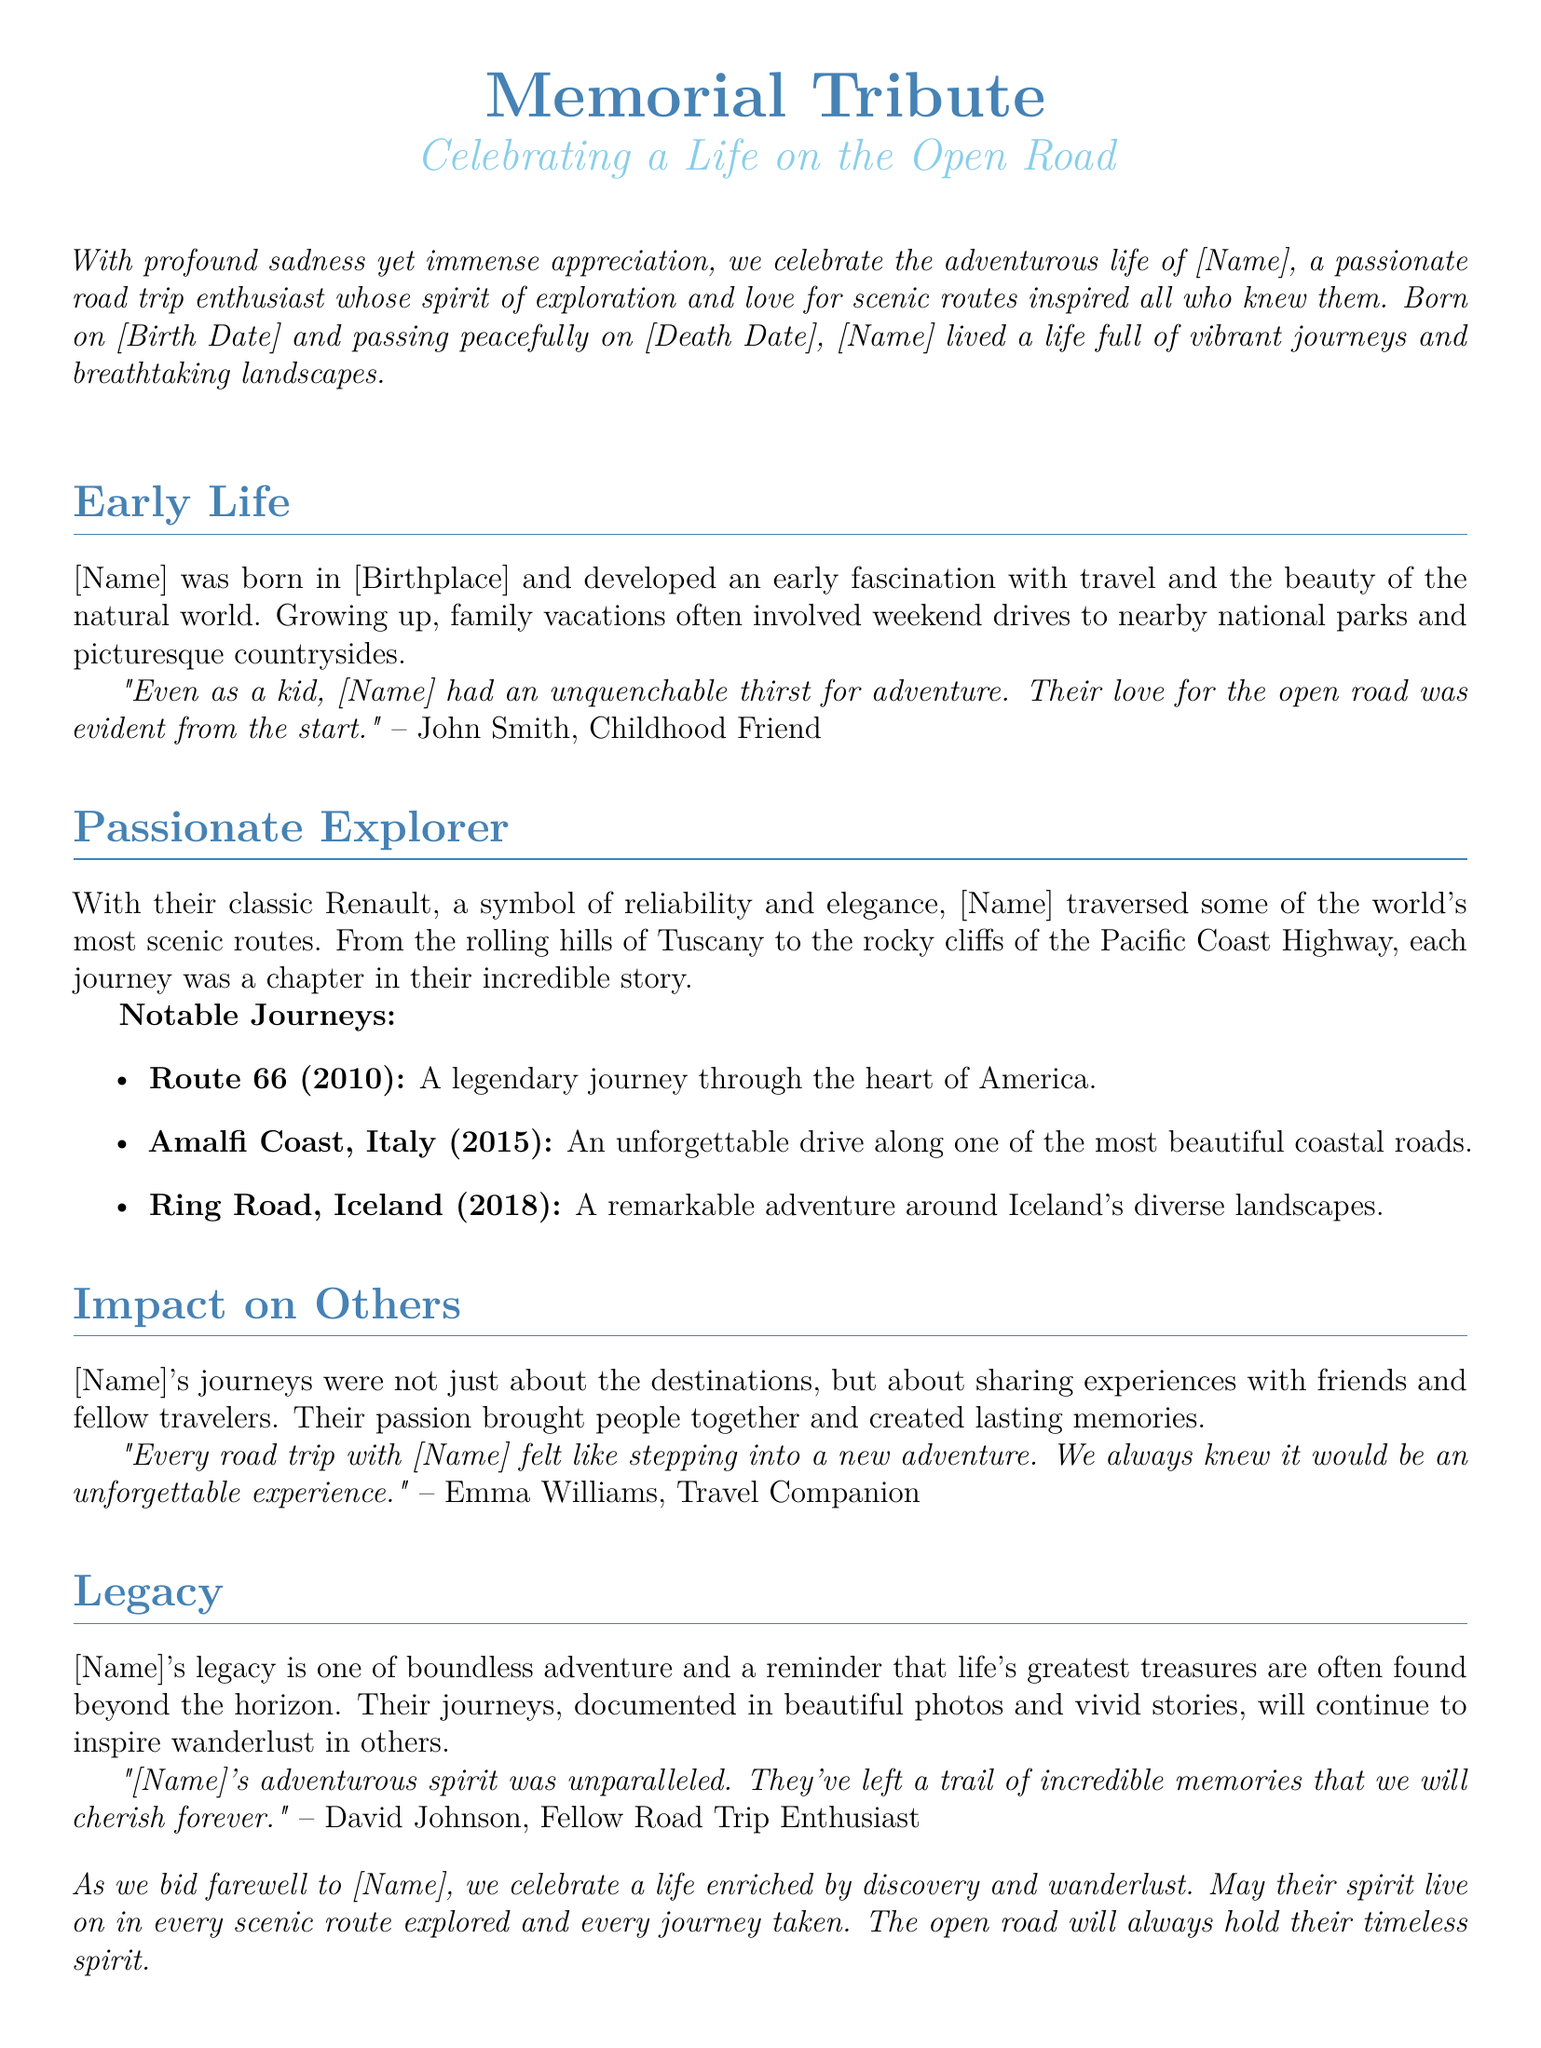What was [Name]'s birth date? The document states that [Name] was born on [Birth Date], which is provided as a placeholder.
Answer: [Birth Date] What is the title of the tribute? The title of the tribute is explicitly mentioned at the beginning of the document.
Answer: Memorial Tribute Which classic car did [Name] drive? The document mentions that [Name] drove a classic Renault, symbolizing reliability and elegance.
Answer: classic Renault What was one location [Name] traveled to in 2015? The document lists notable journeys, one of which is to the Amalfi Coast in Italy in 2015.
Answer: Amalfi Coast, Italy Who is quoted as a childhood friend? The document attributes a quote to John Smith, identified as a childhood friend of [Name].
Answer: John Smith What does [Name]'s legacy remind us of? The document notes that [Name]'s legacy serves as a reminder that life's treasures are often beyond the horizon.
Answer: life's greatest treasures What type of experiences did [Name] share with others? The document describes that [Name]'s journeys were about sharing experiences with friends and fellow travelers.
Answer: experiences How did [Name]'s friends describe their road trips? Friends described every road trip with [Name] as stepping into a new adventure and unforgettable experience.
Answer: unforgettable experience What did [Name]'s spirit inspire in others? The document mentions that [Name]'s spirit continues to inspire wanderlust in others.
Answer: wanderlust 